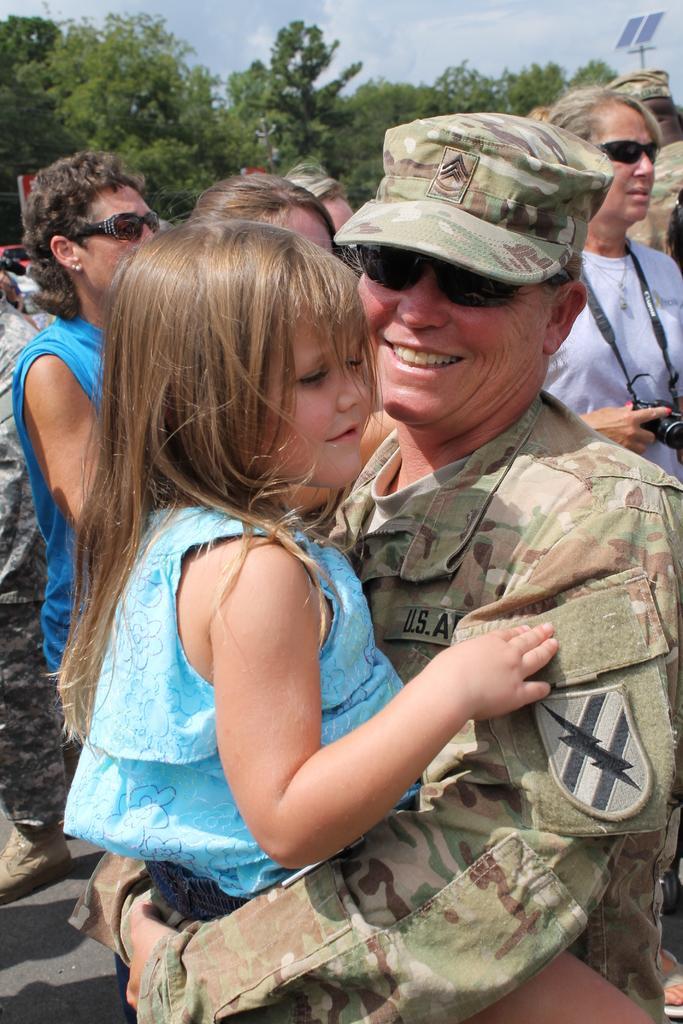Please provide a concise description of this image. In this image I can see a person wearing military uniform is standing and holding a girl who is wearing blue colored dress. In the background I can see few persons standing, few trees and the sky. 